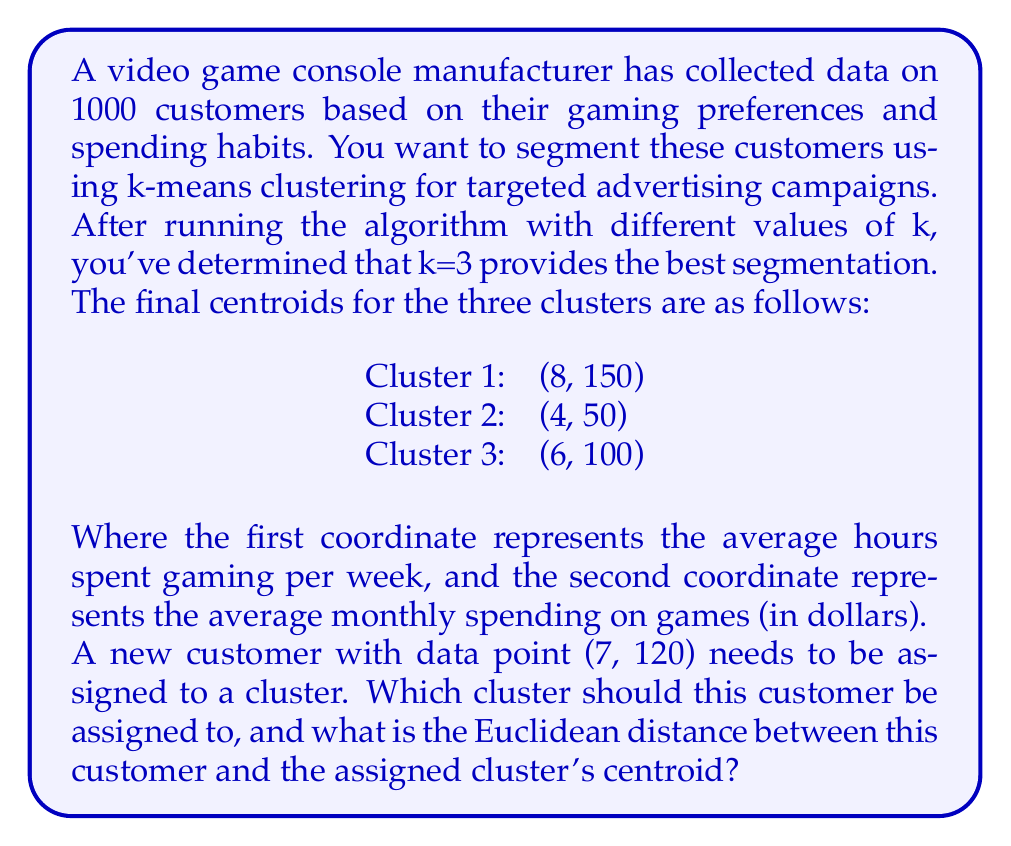Provide a solution to this math problem. To solve this problem, we need to calculate the Euclidean distance between the new customer's data point and each of the cluster centroids. The new customer will be assigned to the cluster with the smallest distance.

The Euclidean distance between two points $(x_1, y_1)$ and $(x_2, y_2)$ in a 2D space is given by:

$$d = \sqrt{(x_2 - x_1)^2 + (y_2 - y_1)^2}$$

Let's calculate the distance to each cluster centroid:

1. Distance to Cluster 1 centroid (8, 150):
   $$d_1 = \sqrt{(8 - 7)^2 + (150 - 120)^2} = \sqrt{1^2 + 30^2} = \sqrt{901} \approx 30.02$$

2. Distance to Cluster 2 centroid (4, 50):
   $$d_2 = \sqrt{(4 - 7)^2 + (50 - 120)^2} = \sqrt{(-3)^2 + (-70)^2} = \sqrt{4909} \approx 70.06$$

3. Distance to Cluster 3 centroid (6, 100):
   $$d_3 = \sqrt{(6 - 7)^2 + (100 - 120)^2} = \sqrt{(-1)^2 + (-20)^2} = \sqrt{401} \approx 20.02$$

The smallest distance is to Cluster 3, so the new customer should be assigned to this cluster. The Euclidean distance between the new customer and Cluster 3's centroid is approximately 20.02.
Answer: The new customer should be assigned to Cluster 3, and the Euclidean distance between this customer and Cluster 3's centroid is approximately 20.02. 